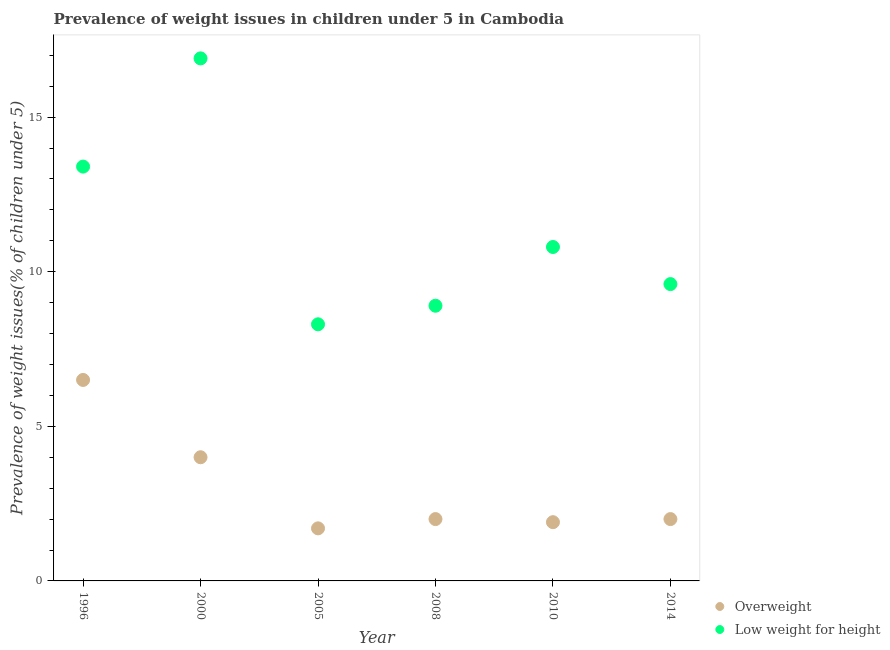Is the number of dotlines equal to the number of legend labels?
Ensure brevity in your answer.  Yes. What is the percentage of overweight children in 2005?
Offer a terse response. 1.7. Across all years, what is the maximum percentage of overweight children?
Your response must be concise. 6.5. Across all years, what is the minimum percentage of overweight children?
Keep it short and to the point. 1.7. What is the total percentage of overweight children in the graph?
Make the answer very short. 18.1. What is the difference between the percentage of underweight children in 2005 and that in 2008?
Provide a short and direct response. -0.6. What is the difference between the percentage of underweight children in 1996 and the percentage of overweight children in 2000?
Ensure brevity in your answer.  9.4. What is the average percentage of overweight children per year?
Make the answer very short. 3.02. In the year 2008, what is the difference between the percentage of underweight children and percentage of overweight children?
Your response must be concise. 6.9. What is the ratio of the percentage of underweight children in 1996 to that in 2014?
Provide a succinct answer. 1.4. Is the difference between the percentage of underweight children in 1996 and 2000 greater than the difference between the percentage of overweight children in 1996 and 2000?
Offer a very short reply. No. What is the difference between the highest and the second highest percentage of underweight children?
Provide a short and direct response. 3.5. What is the difference between the highest and the lowest percentage of underweight children?
Keep it short and to the point. 8.6. In how many years, is the percentage of overweight children greater than the average percentage of overweight children taken over all years?
Keep it short and to the point. 2. Is the percentage of underweight children strictly less than the percentage of overweight children over the years?
Your answer should be very brief. No. How many years are there in the graph?
Your response must be concise. 6. Does the graph contain any zero values?
Make the answer very short. No. Does the graph contain grids?
Make the answer very short. No. Where does the legend appear in the graph?
Your response must be concise. Bottom right. How many legend labels are there?
Ensure brevity in your answer.  2. What is the title of the graph?
Give a very brief answer. Prevalence of weight issues in children under 5 in Cambodia. Does "Female labor force" appear as one of the legend labels in the graph?
Your answer should be compact. No. What is the label or title of the Y-axis?
Your answer should be very brief. Prevalence of weight issues(% of children under 5). What is the Prevalence of weight issues(% of children under 5) in Low weight for height in 1996?
Offer a terse response. 13.4. What is the Prevalence of weight issues(% of children under 5) of Overweight in 2000?
Make the answer very short. 4. What is the Prevalence of weight issues(% of children under 5) of Low weight for height in 2000?
Offer a very short reply. 16.9. What is the Prevalence of weight issues(% of children under 5) of Overweight in 2005?
Make the answer very short. 1.7. What is the Prevalence of weight issues(% of children under 5) in Low weight for height in 2005?
Offer a very short reply. 8.3. What is the Prevalence of weight issues(% of children under 5) in Overweight in 2008?
Your answer should be very brief. 2. What is the Prevalence of weight issues(% of children under 5) of Low weight for height in 2008?
Your answer should be compact. 8.9. What is the Prevalence of weight issues(% of children under 5) in Overweight in 2010?
Ensure brevity in your answer.  1.9. What is the Prevalence of weight issues(% of children under 5) of Low weight for height in 2010?
Ensure brevity in your answer.  10.8. What is the Prevalence of weight issues(% of children under 5) of Overweight in 2014?
Keep it short and to the point. 2. What is the Prevalence of weight issues(% of children under 5) of Low weight for height in 2014?
Give a very brief answer. 9.6. Across all years, what is the maximum Prevalence of weight issues(% of children under 5) in Low weight for height?
Give a very brief answer. 16.9. Across all years, what is the minimum Prevalence of weight issues(% of children under 5) of Overweight?
Provide a short and direct response. 1.7. Across all years, what is the minimum Prevalence of weight issues(% of children under 5) of Low weight for height?
Provide a succinct answer. 8.3. What is the total Prevalence of weight issues(% of children under 5) of Low weight for height in the graph?
Ensure brevity in your answer.  67.9. What is the difference between the Prevalence of weight issues(% of children under 5) of Overweight in 1996 and that in 2000?
Provide a short and direct response. 2.5. What is the difference between the Prevalence of weight issues(% of children under 5) of Overweight in 1996 and that in 2005?
Keep it short and to the point. 4.8. What is the difference between the Prevalence of weight issues(% of children under 5) of Low weight for height in 1996 and that in 2005?
Your answer should be compact. 5.1. What is the difference between the Prevalence of weight issues(% of children under 5) in Overweight in 1996 and that in 2008?
Provide a succinct answer. 4.5. What is the difference between the Prevalence of weight issues(% of children under 5) of Low weight for height in 1996 and that in 2008?
Offer a terse response. 4.5. What is the difference between the Prevalence of weight issues(% of children under 5) of Overweight in 1996 and that in 2014?
Provide a short and direct response. 4.5. What is the difference between the Prevalence of weight issues(% of children under 5) in Overweight in 2000 and that in 2008?
Your answer should be compact. 2. What is the difference between the Prevalence of weight issues(% of children under 5) of Overweight in 2000 and that in 2010?
Provide a short and direct response. 2.1. What is the difference between the Prevalence of weight issues(% of children under 5) of Low weight for height in 2000 and that in 2010?
Give a very brief answer. 6.1. What is the difference between the Prevalence of weight issues(% of children under 5) in Overweight in 2000 and that in 2014?
Provide a succinct answer. 2. What is the difference between the Prevalence of weight issues(% of children under 5) of Low weight for height in 2000 and that in 2014?
Offer a terse response. 7.3. What is the difference between the Prevalence of weight issues(% of children under 5) of Low weight for height in 2008 and that in 2010?
Ensure brevity in your answer.  -1.9. What is the difference between the Prevalence of weight issues(% of children under 5) of Overweight in 2008 and that in 2014?
Your response must be concise. 0. What is the difference between the Prevalence of weight issues(% of children under 5) of Low weight for height in 2008 and that in 2014?
Offer a terse response. -0.7. What is the difference between the Prevalence of weight issues(% of children under 5) in Low weight for height in 2010 and that in 2014?
Offer a very short reply. 1.2. What is the difference between the Prevalence of weight issues(% of children under 5) of Overweight in 1996 and the Prevalence of weight issues(% of children under 5) of Low weight for height in 2008?
Ensure brevity in your answer.  -2.4. What is the difference between the Prevalence of weight issues(% of children under 5) in Overweight in 1996 and the Prevalence of weight issues(% of children under 5) in Low weight for height in 2014?
Offer a very short reply. -3.1. What is the difference between the Prevalence of weight issues(% of children under 5) in Overweight in 2000 and the Prevalence of weight issues(% of children under 5) in Low weight for height in 2008?
Keep it short and to the point. -4.9. What is the difference between the Prevalence of weight issues(% of children under 5) in Overweight in 2000 and the Prevalence of weight issues(% of children under 5) in Low weight for height in 2014?
Make the answer very short. -5.6. What is the difference between the Prevalence of weight issues(% of children under 5) in Overweight in 2005 and the Prevalence of weight issues(% of children under 5) in Low weight for height in 2010?
Keep it short and to the point. -9.1. What is the difference between the Prevalence of weight issues(% of children under 5) in Overweight in 2010 and the Prevalence of weight issues(% of children under 5) in Low weight for height in 2014?
Keep it short and to the point. -7.7. What is the average Prevalence of weight issues(% of children under 5) in Overweight per year?
Give a very brief answer. 3.02. What is the average Prevalence of weight issues(% of children under 5) in Low weight for height per year?
Your answer should be very brief. 11.32. In the year 1996, what is the difference between the Prevalence of weight issues(% of children under 5) of Overweight and Prevalence of weight issues(% of children under 5) of Low weight for height?
Your answer should be very brief. -6.9. In the year 2005, what is the difference between the Prevalence of weight issues(% of children under 5) in Overweight and Prevalence of weight issues(% of children under 5) in Low weight for height?
Make the answer very short. -6.6. In the year 2008, what is the difference between the Prevalence of weight issues(% of children under 5) of Overweight and Prevalence of weight issues(% of children under 5) of Low weight for height?
Offer a terse response. -6.9. What is the ratio of the Prevalence of weight issues(% of children under 5) in Overweight in 1996 to that in 2000?
Keep it short and to the point. 1.62. What is the ratio of the Prevalence of weight issues(% of children under 5) of Low weight for height in 1996 to that in 2000?
Make the answer very short. 0.79. What is the ratio of the Prevalence of weight issues(% of children under 5) of Overweight in 1996 to that in 2005?
Your answer should be very brief. 3.82. What is the ratio of the Prevalence of weight issues(% of children under 5) in Low weight for height in 1996 to that in 2005?
Make the answer very short. 1.61. What is the ratio of the Prevalence of weight issues(% of children under 5) of Low weight for height in 1996 to that in 2008?
Your answer should be compact. 1.51. What is the ratio of the Prevalence of weight issues(% of children under 5) in Overweight in 1996 to that in 2010?
Ensure brevity in your answer.  3.42. What is the ratio of the Prevalence of weight issues(% of children under 5) of Low weight for height in 1996 to that in 2010?
Offer a terse response. 1.24. What is the ratio of the Prevalence of weight issues(% of children under 5) of Low weight for height in 1996 to that in 2014?
Ensure brevity in your answer.  1.4. What is the ratio of the Prevalence of weight issues(% of children under 5) in Overweight in 2000 to that in 2005?
Offer a terse response. 2.35. What is the ratio of the Prevalence of weight issues(% of children under 5) of Low weight for height in 2000 to that in 2005?
Ensure brevity in your answer.  2.04. What is the ratio of the Prevalence of weight issues(% of children under 5) of Overweight in 2000 to that in 2008?
Ensure brevity in your answer.  2. What is the ratio of the Prevalence of weight issues(% of children under 5) in Low weight for height in 2000 to that in 2008?
Offer a terse response. 1.9. What is the ratio of the Prevalence of weight issues(% of children under 5) in Overweight in 2000 to that in 2010?
Ensure brevity in your answer.  2.11. What is the ratio of the Prevalence of weight issues(% of children under 5) of Low weight for height in 2000 to that in 2010?
Make the answer very short. 1.56. What is the ratio of the Prevalence of weight issues(% of children under 5) of Low weight for height in 2000 to that in 2014?
Offer a terse response. 1.76. What is the ratio of the Prevalence of weight issues(% of children under 5) of Overweight in 2005 to that in 2008?
Make the answer very short. 0.85. What is the ratio of the Prevalence of weight issues(% of children under 5) of Low weight for height in 2005 to that in 2008?
Provide a succinct answer. 0.93. What is the ratio of the Prevalence of weight issues(% of children under 5) of Overweight in 2005 to that in 2010?
Your response must be concise. 0.89. What is the ratio of the Prevalence of weight issues(% of children under 5) in Low weight for height in 2005 to that in 2010?
Keep it short and to the point. 0.77. What is the ratio of the Prevalence of weight issues(% of children under 5) of Overweight in 2005 to that in 2014?
Keep it short and to the point. 0.85. What is the ratio of the Prevalence of weight issues(% of children under 5) in Low weight for height in 2005 to that in 2014?
Your answer should be compact. 0.86. What is the ratio of the Prevalence of weight issues(% of children under 5) in Overweight in 2008 to that in 2010?
Provide a succinct answer. 1.05. What is the ratio of the Prevalence of weight issues(% of children under 5) of Low weight for height in 2008 to that in 2010?
Offer a terse response. 0.82. What is the ratio of the Prevalence of weight issues(% of children under 5) in Overweight in 2008 to that in 2014?
Your response must be concise. 1. What is the ratio of the Prevalence of weight issues(% of children under 5) of Low weight for height in 2008 to that in 2014?
Your answer should be compact. 0.93. What is the ratio of the Prevalence of weight issues(% of children under 5) in Overweight in 2010 to that in 2014?
Offer a very short reply. 0.95. What is the ratio of the Prevalence of weight issues(% of children under 5) of Low weight for height in 2010 to that in 2014?
Offer a terse response. 1.12. What is the difference between the highest and the second highest Prevalence of weight issues(% of children under 5) of Overweight?
Give a very brief answer. 2.5. What is the difference between the highest and the lowest Prevalence of weight issues(% of children under 5) of Low weight for height?
Give a very brief answer. 8.6. 